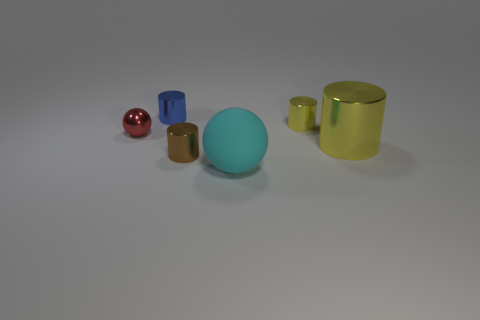Subtract all big cylinders. How many cylinders are left? 3 Subtract all red balls. How many balls are left? 1 Subtract all cylinders. How many objects are left? 2 Add 1 tiny red metallic spheres. How many objects exist? 7 Subtract all cyan things. Subtract all tiny shiny balls. How many objects are left? 4 Add 6 rubber spheres. How many rubber spheres are left? 7 Add 4 cyan matte things. How many cyan matte things exist? 5 Subtract 1 blue cylinders. How many objects are left? 5 Subtract 1 balls. How many balls are left? 1 Subtract all red spheres. Subtract all blue blocks. How many spheres are left? 1 